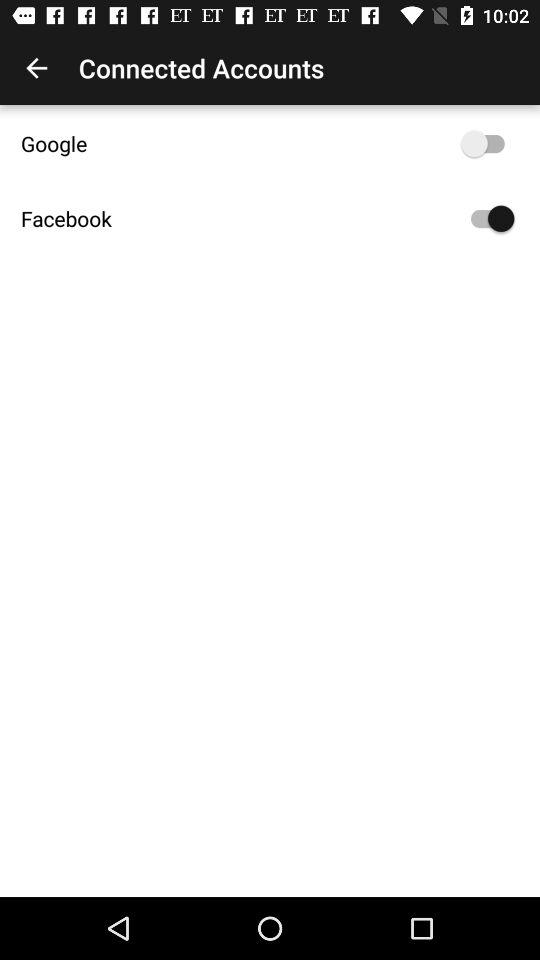What's the status of the "Facebook"? The status is "on". 